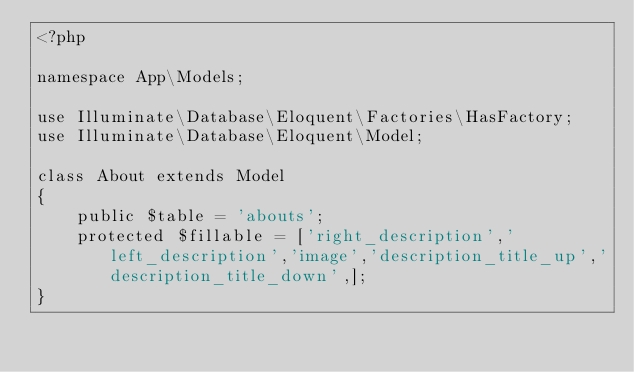Convert code to text. <code><loc_0><loc_0><loc_500><loc_500><_PHP_><?php

namespace App\Models;

use Illuminate\Database\Eloquent\Factories\HasFactory;
use Illuminate\Database\Eloquent\Model;

class About extends Model
{
    public $table = 'abouts';
    protected $fillable = ['right_description','left_description','image','description_title_up','description_title_down',];
}
</code> 